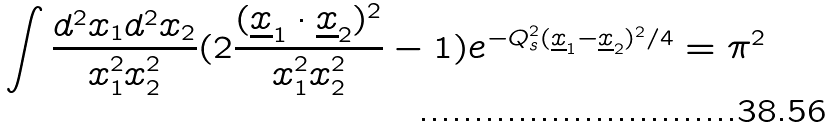Convert formula to latex. <formula><loc_0><loc_0><loc_500><loc_500>\int { \frac { d ^ { 2 } x _ { 1 } d ^ { 2 } x _ { 2 } } { x _ { 1 } ^ { 2 } x _ { 2 } ^ { 2 } } } ( 2 { \frac { ( \underline { x } _ { 1 } \cdot \underline { x } _ { 2 } ) ^ { 2 } } { x _ { 1 } ^ { 2 } x _ { 2 } ^ { 2 } } } - 1 ) e ^ { - Q _ { s } ^ { 2 } ( \underline { x } _ { 1 } - \underline { x } _ { 2 } ) ^ { 2 } / 4 } = \pi ^ { 2 }</formula> 